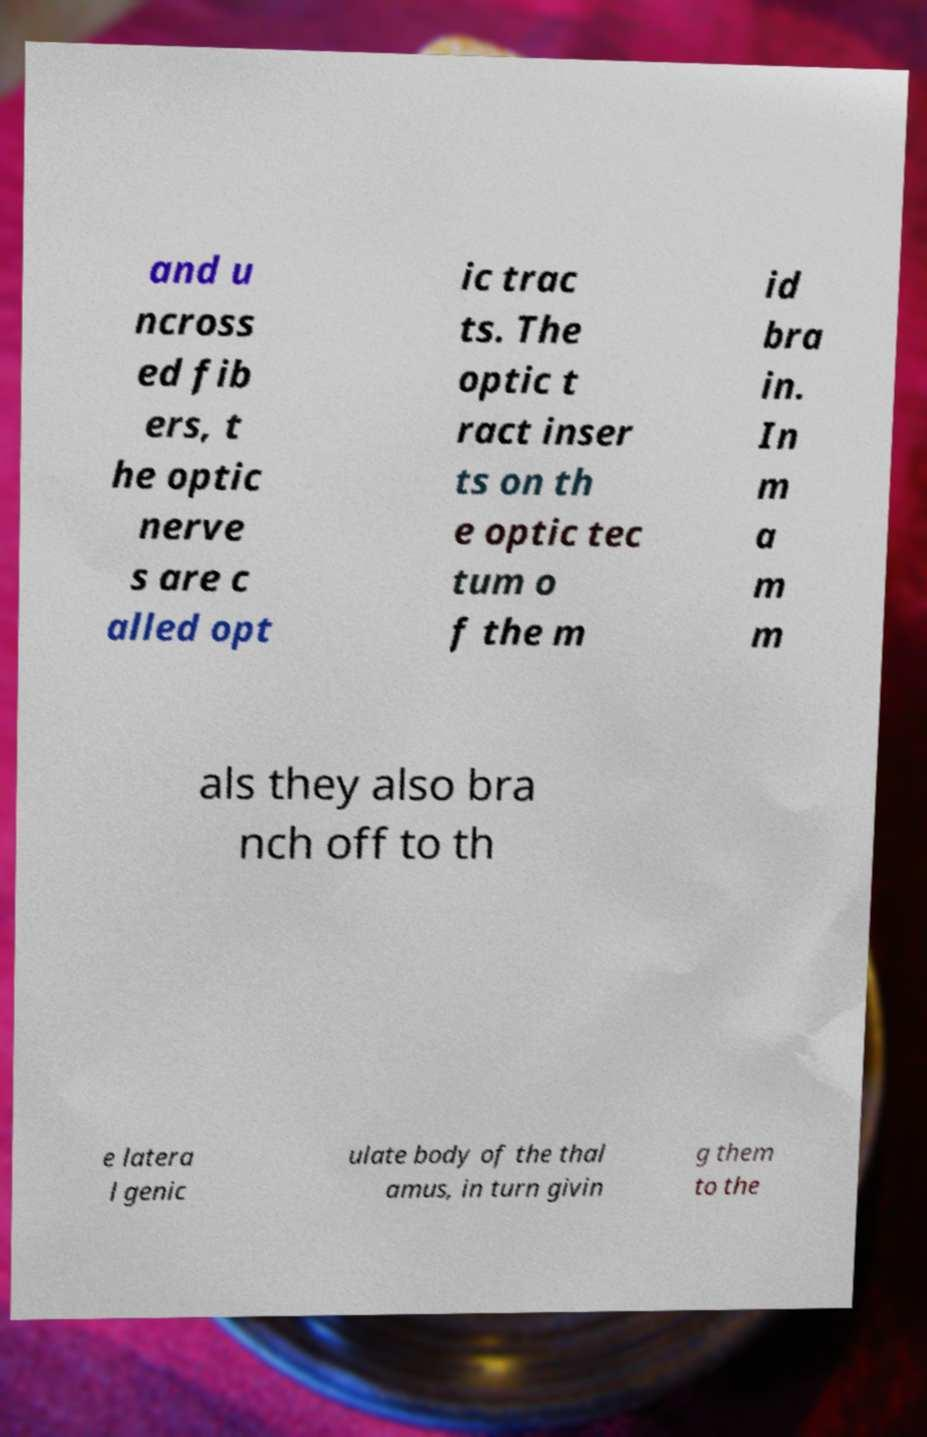Please identify and transcribe the text found in this image. and u ncross ed fib ers, t he optic nerve s are c alled opt ic trac ts. The optic t ract inser ts on th e optic tec tum o f the m id bra in. In m a m m als they also bra nch off to th e latera l genic ulate body of the thal amus, in turn givin g them to the 